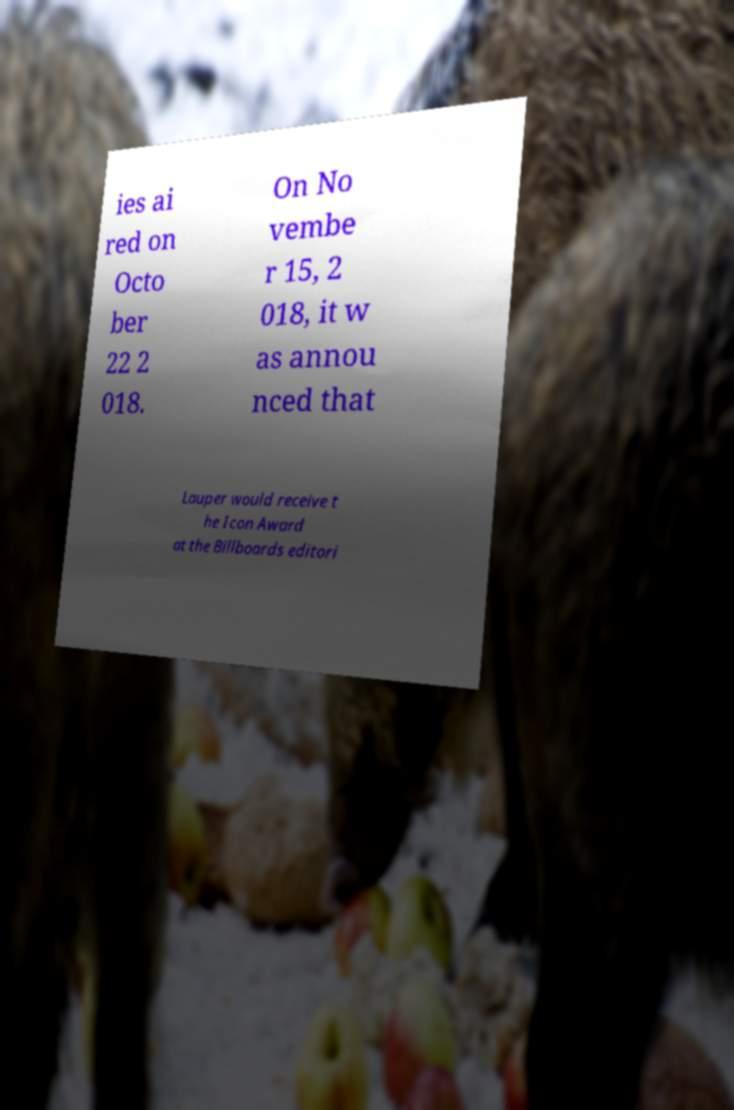What messages or text are displayed in this image? I need them in a readable, typed format. ies ai red on Octo ber 22 2 018. On No vembe r 15, 2 018, it w as annou nced that Lauper would receive t he Icon Award at the Billboards editori 